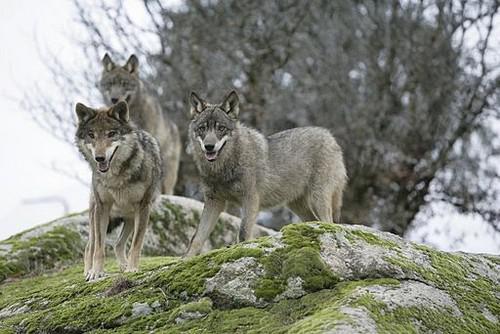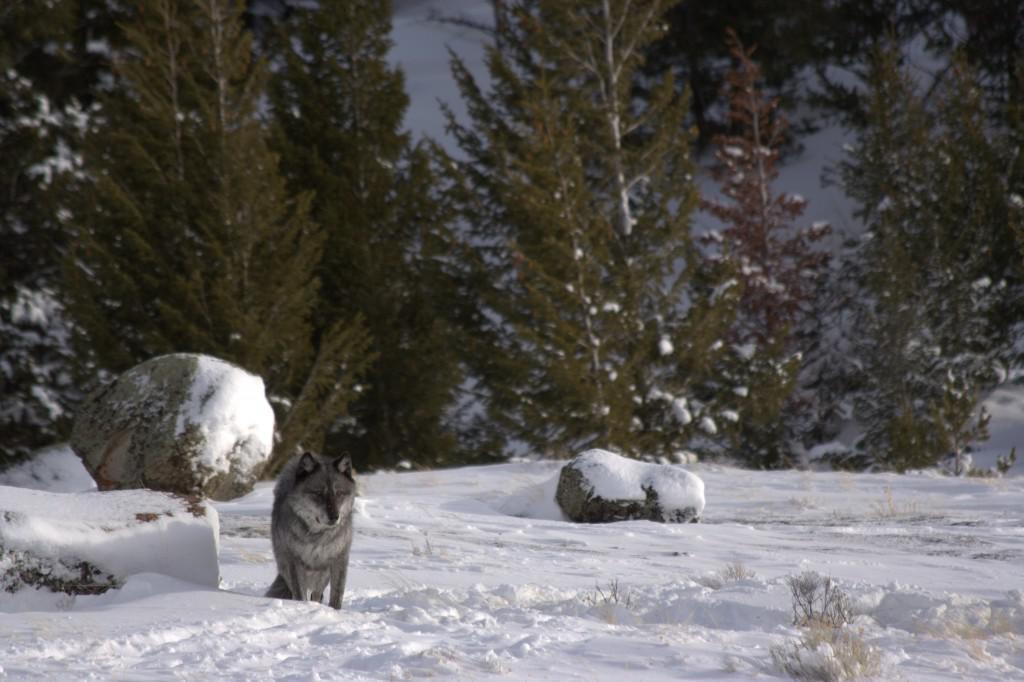The first image is the image on the left, the second image is the image on the right. Examine the images to the left and right. Is the description "Each image contains exactly one wolf, and one image features a wolf that is standing still and looking toward the camera." accurate? Answer yes or no. No. The first image is the image on the left, the second image is the image on the right. Considering the images on both sides, is "The wolves are in a group in at least one picture." valid? Answer yes or no. Yes. 